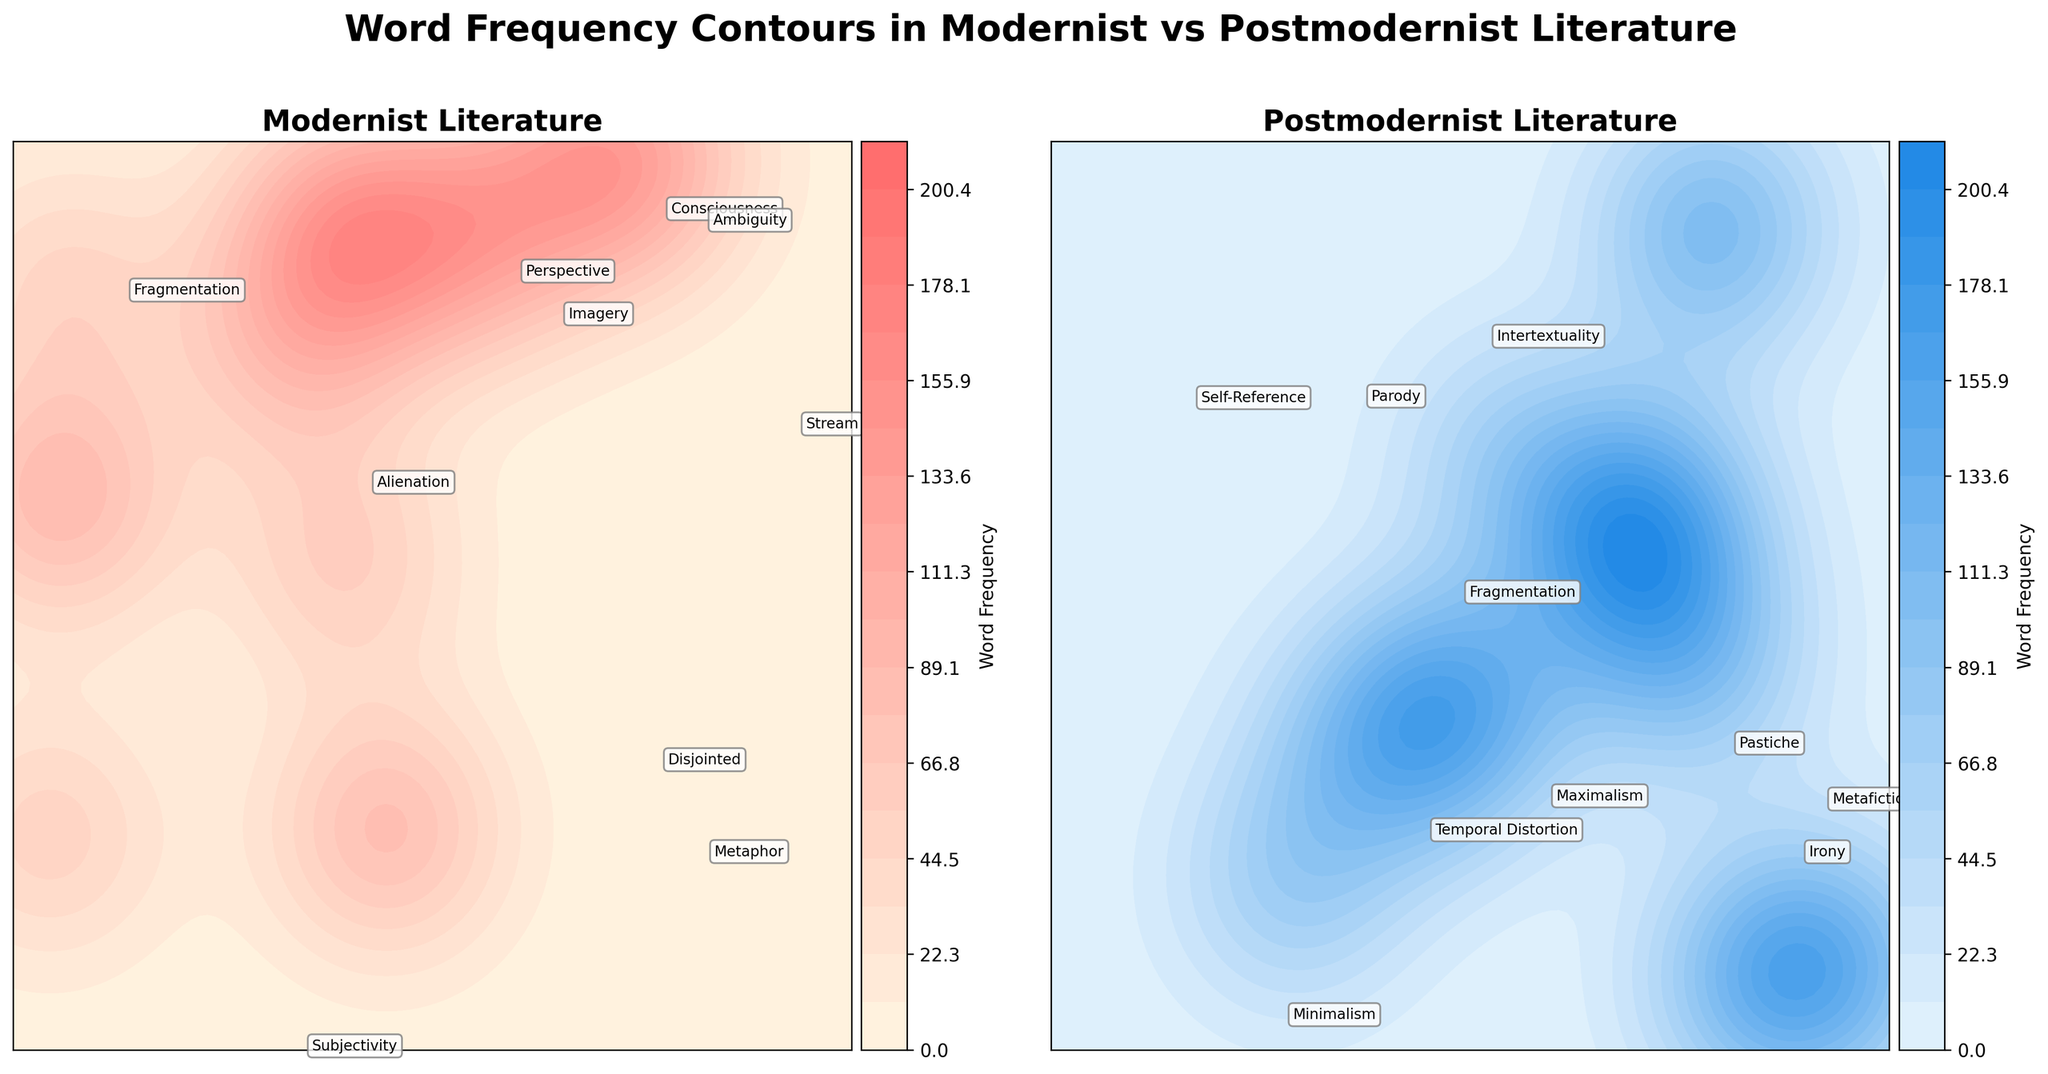What are the central themes in Modernist literature based on the figure? The contour plot for Modernist literature shows annotations with words representing central themes. By looking closely, you can see words like "Stream," "Consciousness," "Perspective," and "Subjectivity," which are prominent.
Answer: Stream, Consciousness, Perspective, Subjectivity Which genre shows a higher overall word frequency according to the color intensity? By comparing the color intensity on both contour plots, we see that the Postmodernist literature's plot has more intense blue shades and higher color intensity, reflecting higher overall word frequencies.
Answer: Postmodernist What is the word situated at the highest frequency point in Postmodernist literature? In the Postmodernist contour plot, the word "Irony" appears prominently and is situated at one of the highest frequency points, based on its annotation location and higher color intensity area around it.
Answer: Irony How does the use of "Fragmentation" differ between Modernist and Postmodernist literature? "Fragmentation" appears in both contour plots. In Modernist literature, the word "Fragmentation" is annotated but embedded in a lighter contour region, implying lower usage. In contrast, "Fragmentation" in Postmodernist literature is also annotated but within a darker contour region, indicating higher usage.
Answer: Higher in Postmodernist Which word in Modernist literature appears to have the lowest usage frequency and how can you tell? The word "Ambiguity" appears near the outer, lighter regions of the Modernist contour plot where color intensity is lower, suggesting it has one of the lowest usage frequencies.
Answer: Ambiguity Are there any common words between Modernist and Postmodernist literature? Identify one. Observing both contour plots, the word "Fragmentation" appears in both Modernist and Postmodernist literature, making it a common term.
Answer: Fragmentation Which genre has more diverse vocabulary based on the number of annotated words, and how do you determine that? By counting the annotated words on each subplot, Postmodernist literature has annotations for more diverse vocabulary with more words being represented compared to Modernist literature.
Answer: Postmodernist Comparing “Irony” in Postmodernist literature and “Stream” in Modernist literature, which has higher frequency? The contour plot for Postmodernist literature shows "Irony" in a darker, more intense region, indicating higher frequency. In contrast, "Stream" in Modernist literature appears in a moderately intense region.
Answer: Irony What does the similarity in word "Ambiguity" in both plots indicate about Modernist and Postmodernist literature? The word "Ambiguity" appears in both plots, suggesting that it is a theme explored in both Modernist and Postmodernist literature, although possibly with different frequencies as indicated by contour intensity.
Answer: Both explore ambiguity 